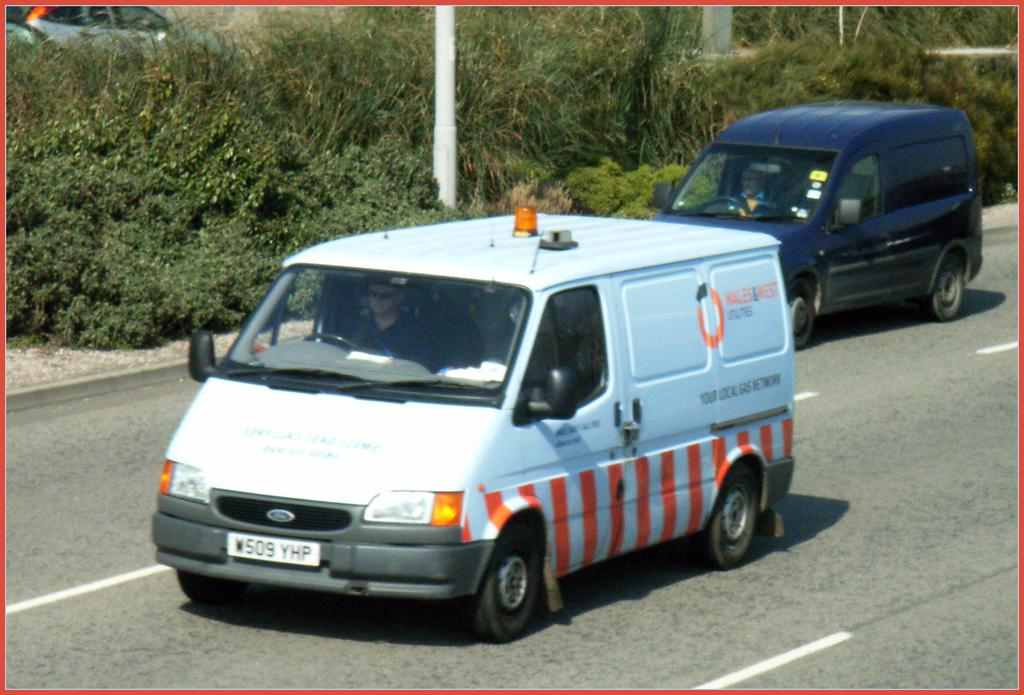How many persons are visible in the image? There are two persons sitting in vehicles in the image. What are the vehicles doing in the image? The vehicles are parked on the road. What else can be seen in the background of the image? There is a vehicle, a pole, and a group of trees in the background of the image. What type of veil is draped over the vehicle in the image? There is no veil present in the image; the vehicles are parked on the road with no additional coverings. 